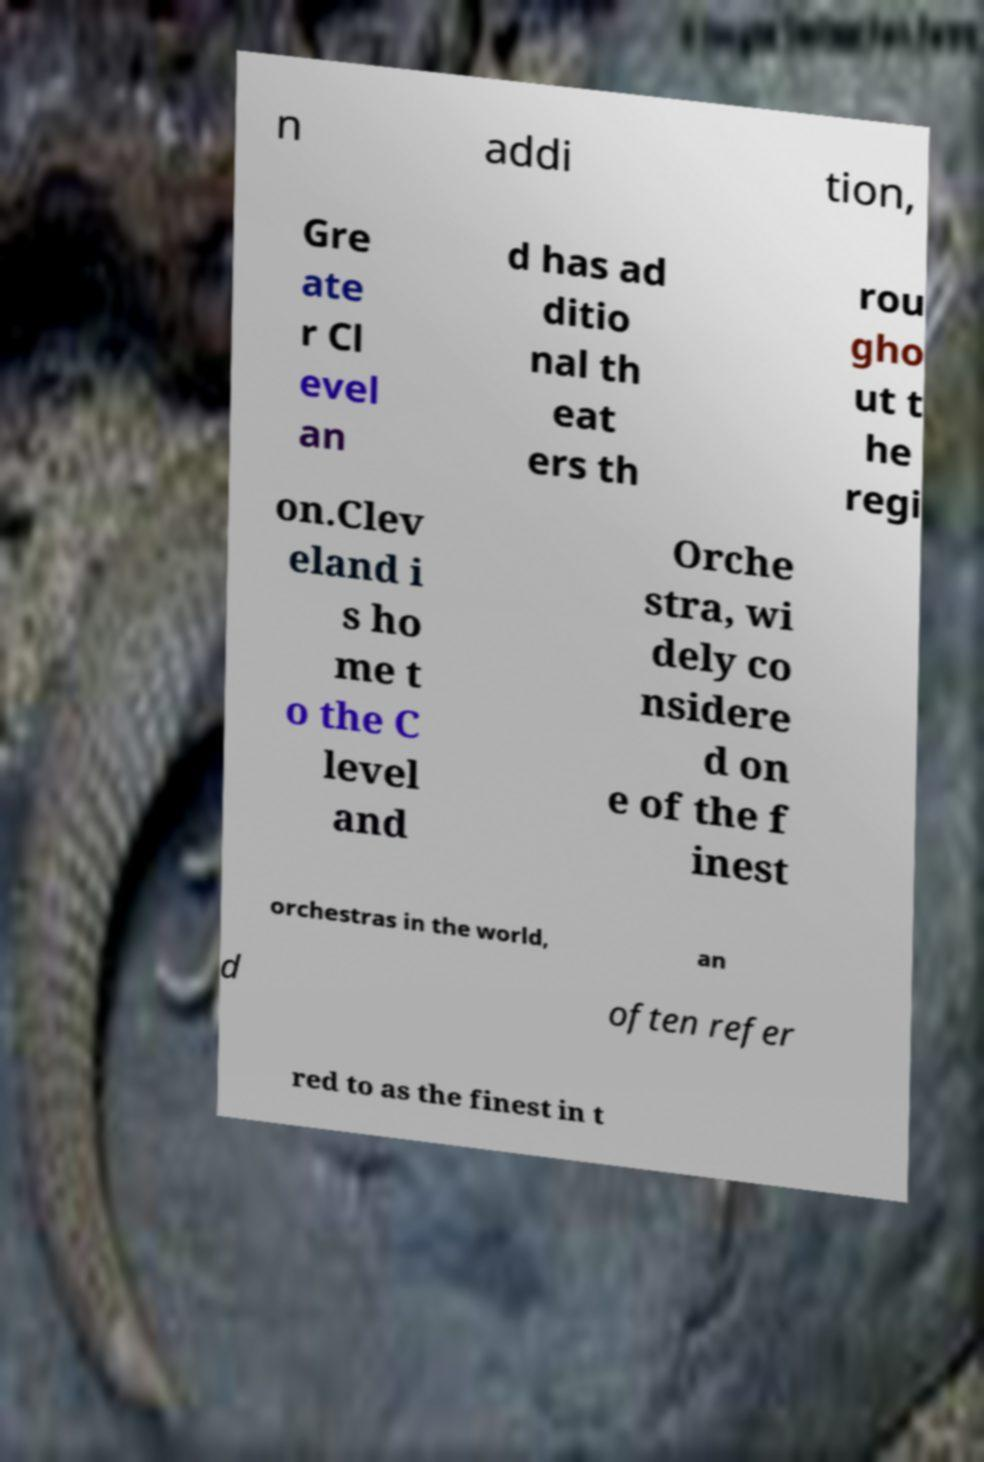Could you extract and type out the text from this image? n addi tion, Gre ate r Cl evel an d has ad ditio nal th eat ers th rou gho ut t he regi on.Clev eland i s ho me t o the C level and Orche stra, wi dely co nsidere d on e of the f inest orchestras in the world, an d often refer red to as the finest in t 